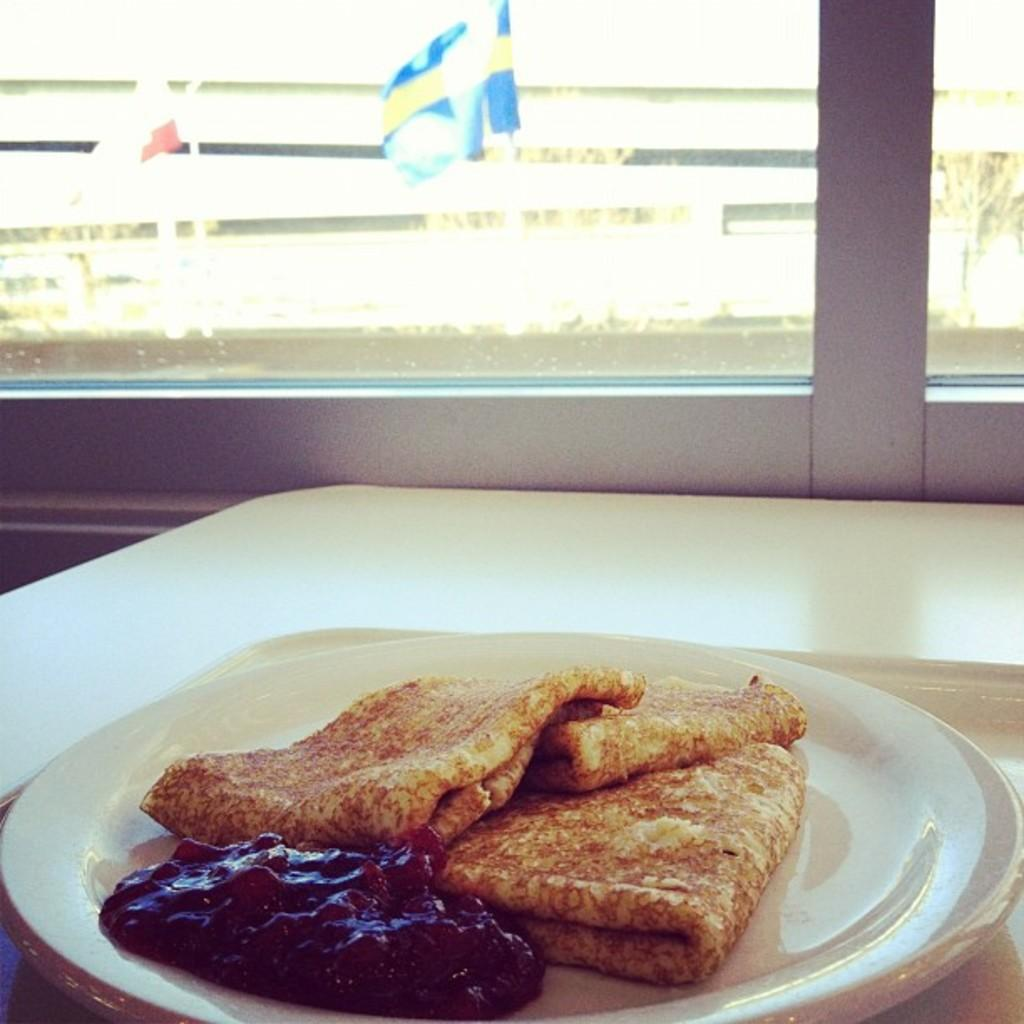What is on the plate in the image? There is a food item on a plate in the image. What is the primary piece of furniture in the image? There is a table in the image. What can be seen through the window glass in the image? The presence of a window glass suggests that something is visible through it, but the specifics are not mentioned in the facts. What is the flag associated with in the image? The flag is present in the image, but not associated with any specific object or event. What type of vegetation is visible in the image? There is a tree in the image, which is a type of vegetation. Reasoning: Let've provided the facts about the image, and we've created questions based on those facts. We've made sure to avoid yes/no questions and to use simple and clear language. Each question is designed to elicit a specific detail about the image that is known from the provided facts. Absurd Question/Answer: What type of payment is being made for the joke in the image? There is no joke or payment present in the image. How many fangs can be seen on the tree in the image? Trees do not have fangs, so this question is not applicable to the image. 